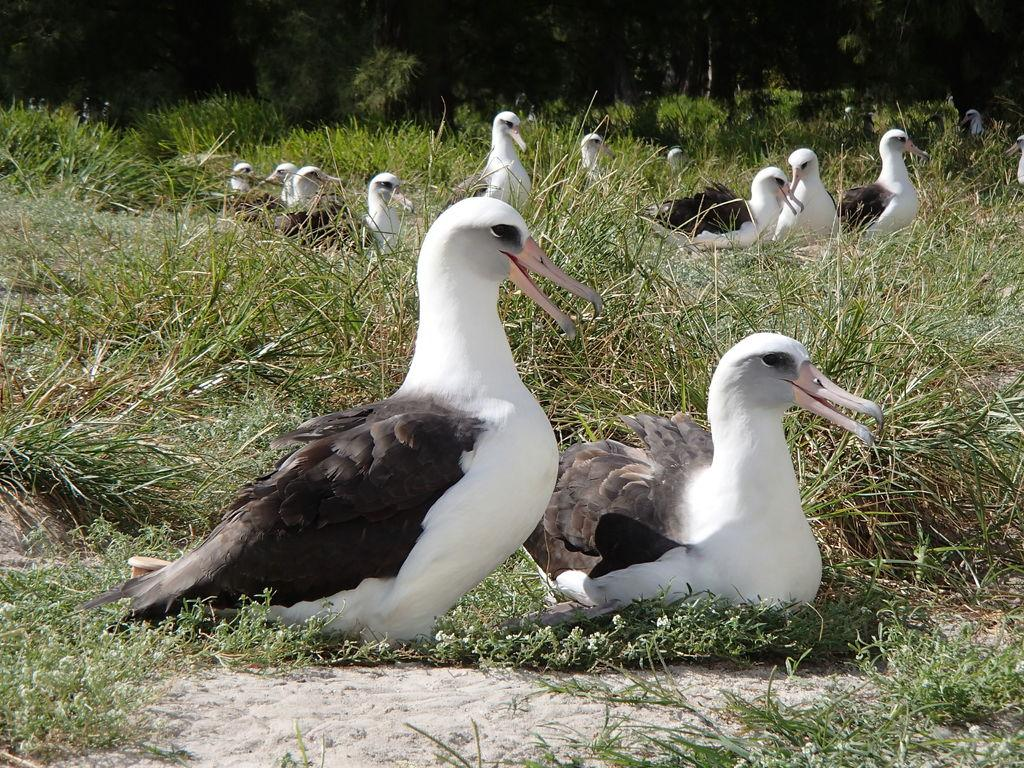What type of animals are in the image? There are ducks in the image. What colors are the ducks? The ducks are in white and black colors. Where are the ducks located in the image? The ducks are on the ground. What type of vegetation is on the ground? There is grass on the ground. What can be seen in the background of the image? There are trees in the background of the image. What type of alarm is going off in the image? There is no alarm present in the image; it features ducks on the ground with grass and trees in the background. 